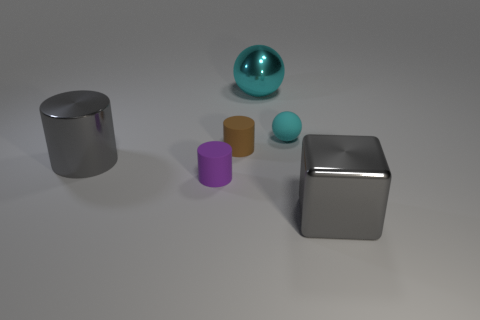What color is the large thing left of the tiny object in front of the big cylinder that is on the left side of the metal block?
Offer a very short reply. Gray. Is the color of the ball that is right of the large cyan ball the same as the large sphere?
Keep it short and to the point. Yes. How many cyan objects are behind the matte sphere and in front of the big cyan metallic object?
Your response must be concise. 0. The purple thing that is the same shape as the brown thing is what size?
Give a very brief answer. Small. There is a thing behind the small thing that is on the right side of the metallic sphere; what number of tiny rubber spheres are left of it?
Offer a terse response. 0. There is a small matte cylinder that is behind the gray metal object on the left side of the cyan metal thing; what is its color?
Offer a very short reply. Brown. What number of other objects are there of the same material as the large cube?
Your response must be concise. 2. What number of tiny brown things are left of the shiny thing behind the matte ball?
Keep it short and to the point. 1. There is a ball behind the tiny cyan matte thing; does it have the same color as the tiny rubber thing that is behind the brown object?
Give a very brief answer. Yes. Is the number of tiny brown objects less than the number of tiny gray cylinders?
Provide a short and direct response. No. 